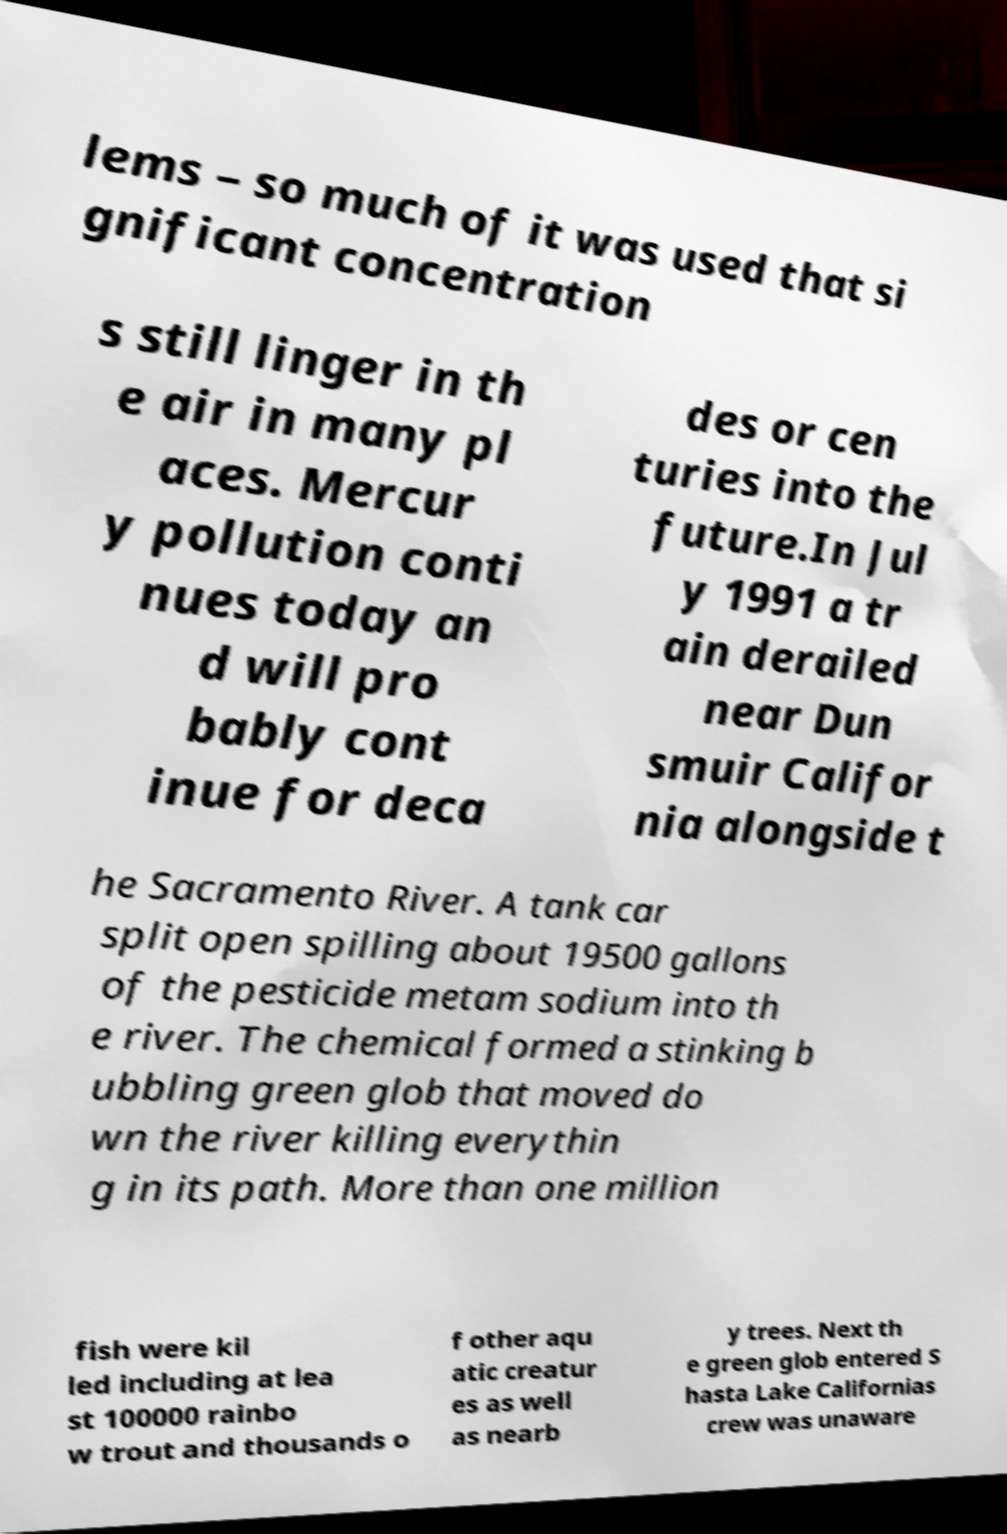I need the written content from this picture converted into text. Can you do that? lems – so much of it was used that si gnificant concentration s still linger in th e air in many pl aces. Mercur y pollution conti nues today an d will pro bably cont inue for deca des or cen turies into the future.In Jul y 1991 a tr ain derailed near Dun smuir Califor nia alongside t he Sacramento River. A tank car split open spilling about 19500 gallons of the pesticide metam sodium into th e river. The chemical formed a stinking b ubbling green glob that moved do wn the river killing everythin g in its path. More than one million fish were kil led including at lea st 100000 rainbo w trout and thousands o f other aqu atic creatur es as well as nearb y trees. Next th e green glob entered S hasta Lake Californias crew was unaware 